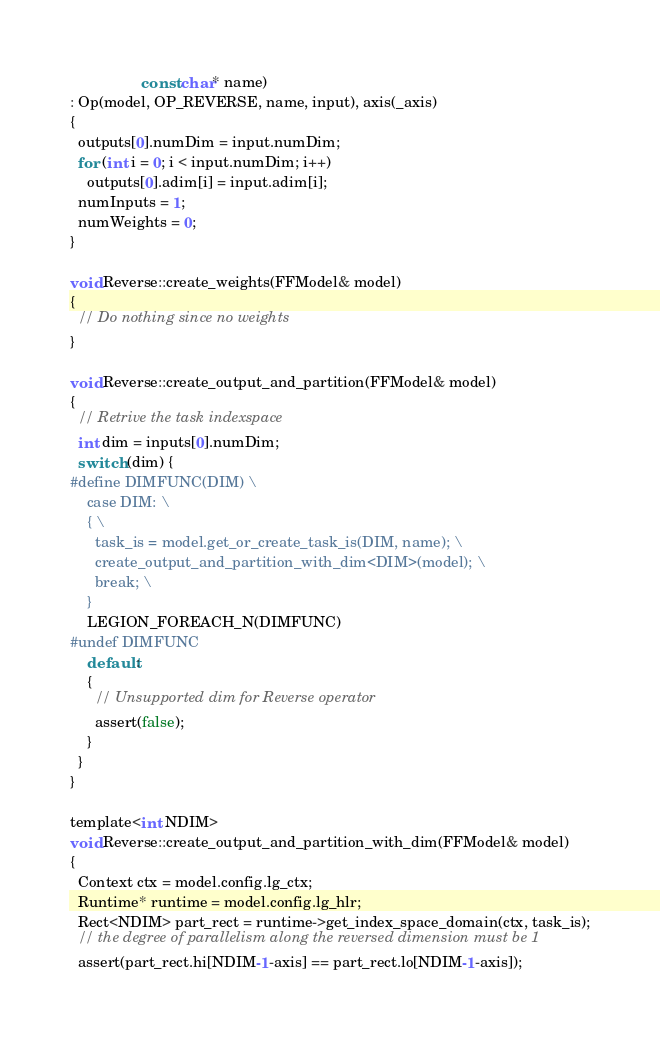<code> <loc_0><loc_0><loc_500><loc_500><_Cuda_>                 const char* name)
: Op(model, OP_REVERSE, name, input), axis(_axis)
{
  outputs[0].numDim = input.numDim;
  for (int i = 0; i < input.numDim; i++)
    outputs[0].adim[i] = input.adim[i];
  numInputs = 1;
  numWeights = 0;
}

void Reverse::create_weights(FFModel& model)
{
  // Do nothing since no weights
}

void Reverse::create_output_and_partition(FFModel& model)
{
  // Retrive the task indexspace
  int dim = inputs[0].numDim;
  switch (dim) {
#define DIMFUNC(DIM) \
    case DIM: \
    { \
      task_is = model.get_or_create_task_is(DIM, name); \
      create_output_and_partition_with_dim<DIM>(model); \
      break; \
    }
    LEGION_FOREACH_N(DIMFUNC)
#undef DIMFUNC
    default:
    {
      // Unsupported dim for Reverse operator
      assert(false);
    }
  }
}

template<int NDIM>
void Reverse::create_output_and_partition_with_dim(FFModel& model)
{
  Context ctx = model.config.lg_ctx;
  Runtime* runtime = model.config.lg_hlr;
  Rect<NDIM> part_rect = runtime->get_index_space_domain(ctx, task_is);
  // the degree of parallelism along the reversed dimension must be 1
  assert(part_rect.hi[NDIM-1-axis] == part_rect.lo[NDIM-1-axis]);</code> 